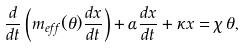<formula> <loc_0><loc_0><loc_500><loc_500>\frac { d } { d t } \left ( m _ { e f f } ( \theta ) \frac { d x } { d t } \right ) + \alpha \frac { d x } { d t } + \kappa x = \chi \, \theta ,</formula> 